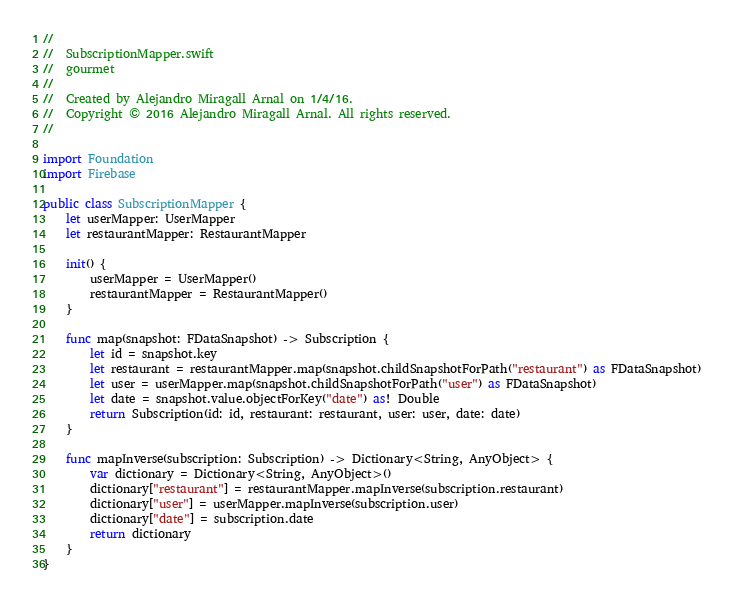Convert code to text. <code><loc_0><loc_0><loc_500><loc_500><_Swift_>//
//  SubscriptionMapper.swift
//  gourmet
//
//  Created by Alejandro Miragall Arnal on 1/4/16.
//  Copyright © 2016 Alejandro Miragall Arnal. All rights reserved.
//

import Foundation
import Firebase

public class SubscriptionMapper {
    let userMapper: UserMapper
    let restaurantMapper: RestaurantMapper
    
    init() {
        userMapper = UserMapper()
        restaurantMapper = RestaurantMapper()
    }
    
    func map(snapshot: FDataSnapshot) -> Subscription {
        let id = snapshot.key
        let restaurant = restaurantMapper.map(snapshot.childSnapshotForPath("restaurant") as FDataSnapshot)
        let user = userMapper.map(snapshot.childSnapshotForPath("user") as FDataSnapshot)
        let date = snapshot.value.objectForKey("date") as! Double
        return Subscription(id: id, restaurant: restaurant, user: user, date: date)
    }
    
    func mapInverse(subscription: Subscription) -> Dictionary<String, AnyObject> {
        var dictionary = Dictionary<String, AnyObject>()
        dictionary["restaurant"] = restaurantMapper.mapInverse(subscription.restaurant)
        dictionary["user"] = userMapper.mapInverse(subscription.user)
        dictionary["date"] = subscription.date
        return dictionary
    }
}
</code> 